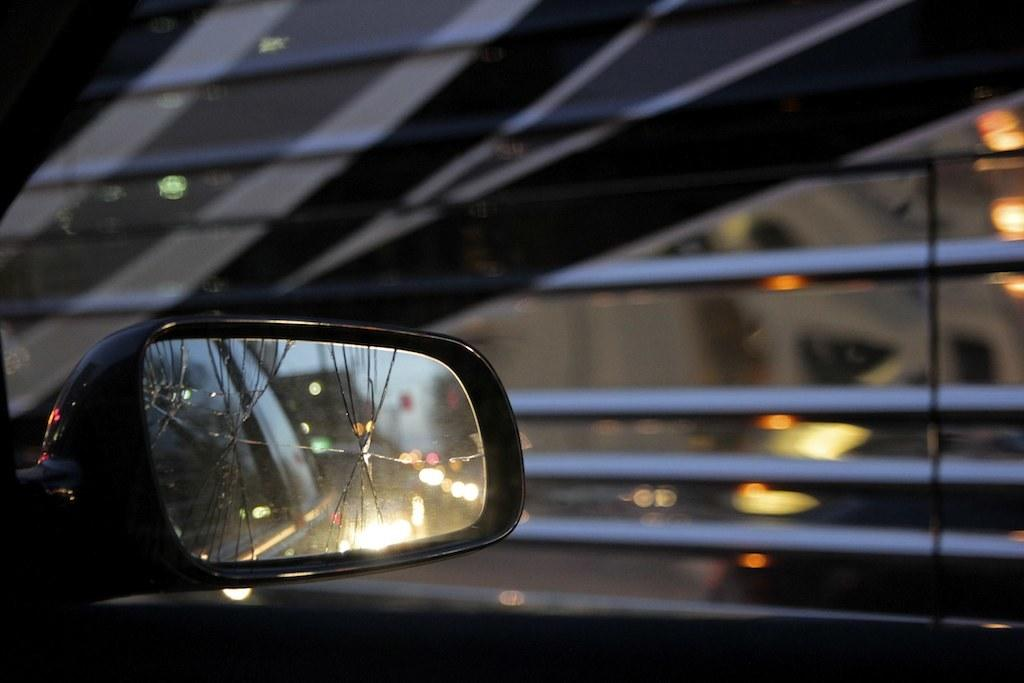What part of a vehicle can be seen in the image? The side mirror of a vehicle is visible in the image. What is the condition of the side mirror? The side mirror is broken. What can be seen in the background of the image? There are lights in the background of the image. How are the lights in the background depicted? The background lights are blurred. What type of fruit is hanging from the broken side mirror in the image? There is no fruit present in the image, and the broken side mirror is not attached to any fruit. 